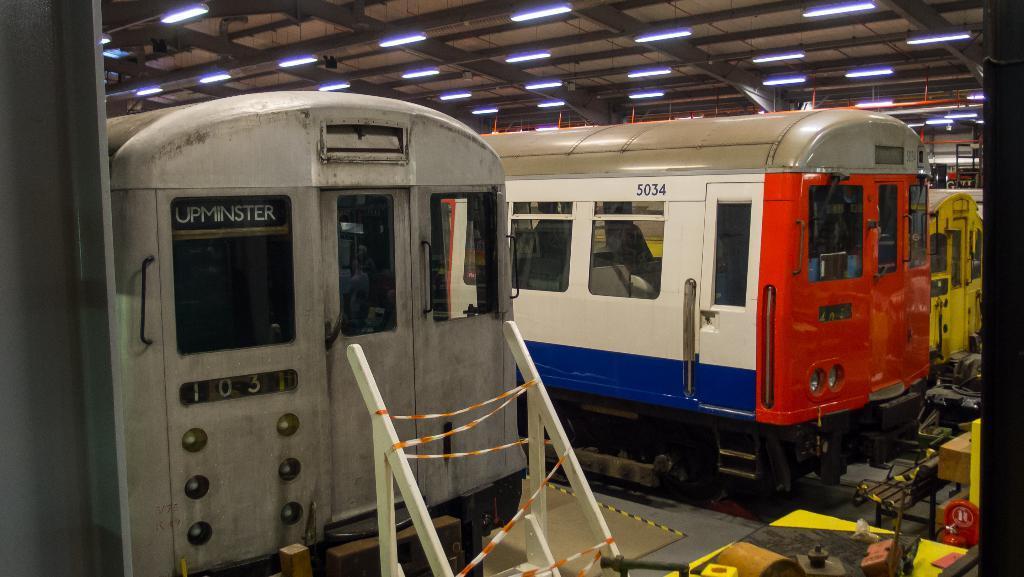In one or two sentences, can you explain what this image depicts? This image is taken indoors. At the top of the image there is a roof and there are many lights. On the left side of the image there is a wall. In the middle of the image there are a few trains on the track. At the right bottom of the image there are a few objects on the floor. In the middle of the image there is an object on the floor. 